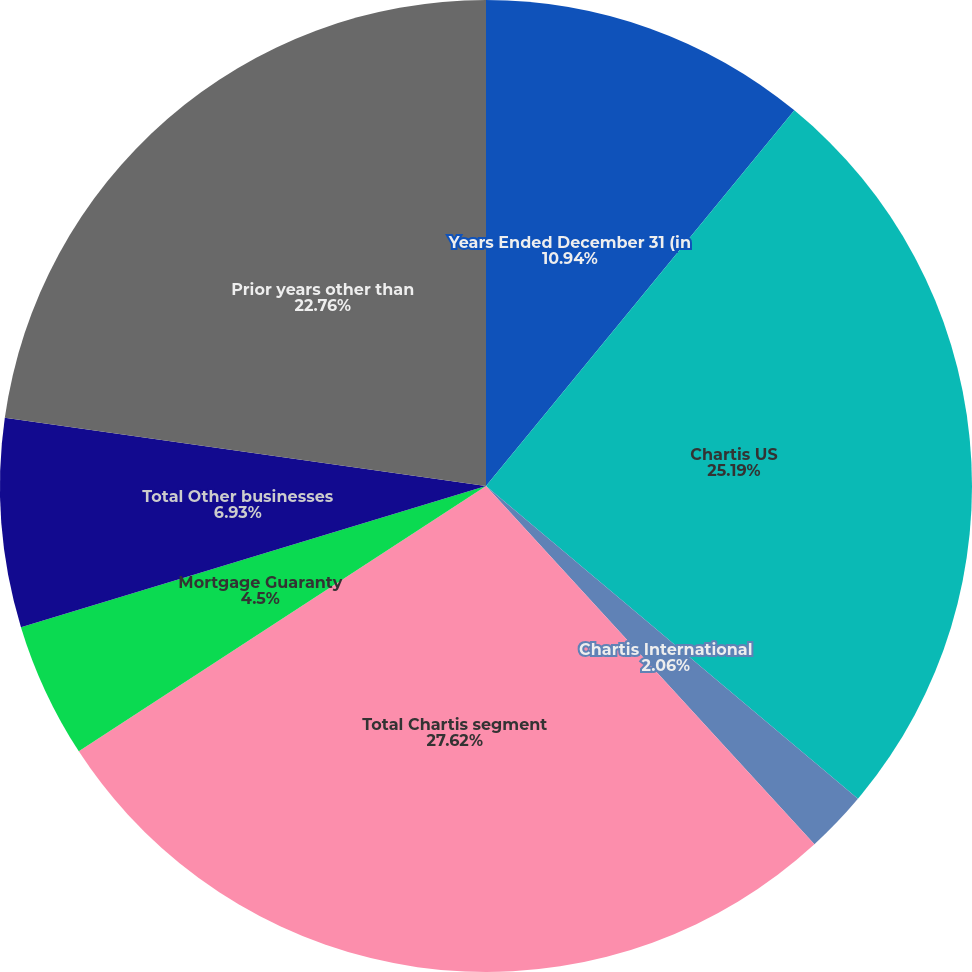Convert chart to OTSL. <chart><loc_0><loc_0><loc_500><loc_500><pie_chart><fcel>Years Ended December 31 (in<fcel>Chartis US<fcel>Chartis International<fcel>Total Chartis segment<fcel>Mortgage Guaranty<fcel>Total Other businesses<fcel>Prior years other than<nl><fcel>10.94%<fcel>25.19%<fcel>2.06%<fcel>27.62%<fcel>4.5%<fcel>6.93%<fcel>22.76%<nl></chart> 